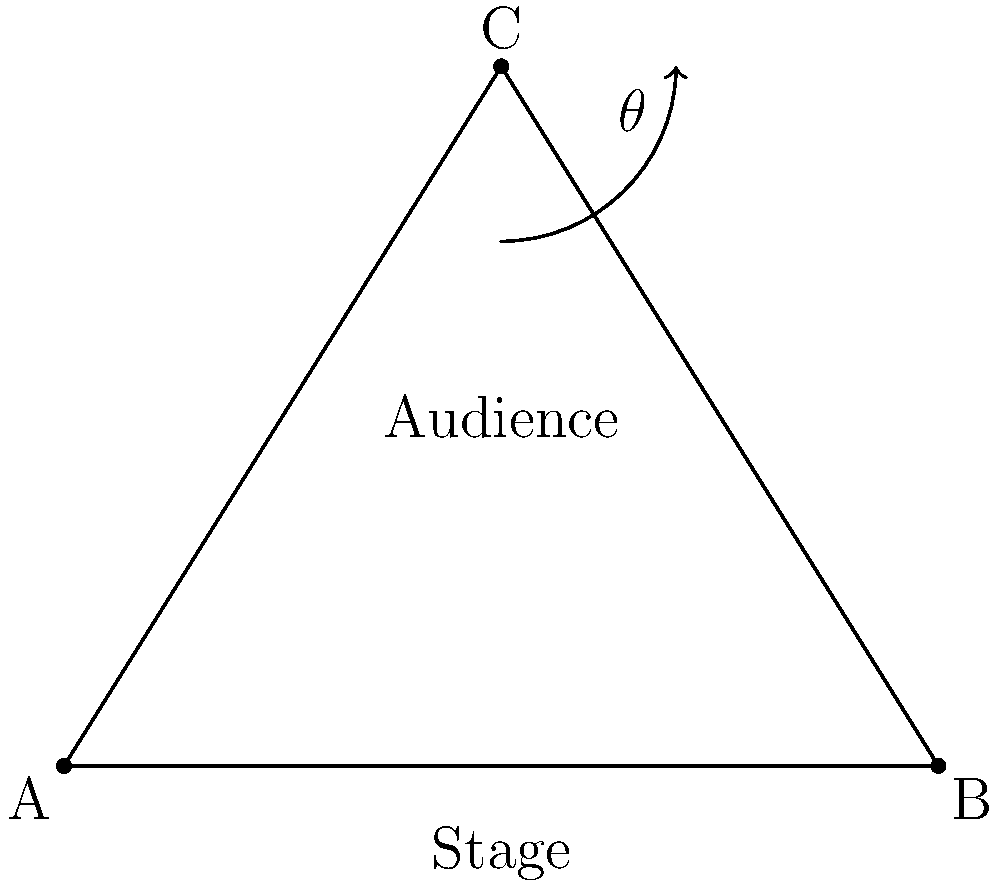In the floor plan for a motivational presentation stage setup, what is the optimal angle $\theta$ for the stage layout to ensure maximum audience engagement and visibility? To determine the optimal angle for the stage layout, we need to consider the principles of presentation design and audience engagement. Here's a step-by-step explanation:

1. The stage layout forms an isosceles triangle ABC, where AB is the stage front and C is the apex point.

2. For optimal visibility and engagement, we want to maximize the angle $\theta$ at point C. This allows for better sight lines and a more immersive experience for the audience.

3. In an isosceles triangle, the largest angle is always opposite the base (in this case, AB). The sum of angles in a triangle is always 180°.

4. To maximize $\theta$, we need to make the other two angles (at A and B) as small as possible while still maintaining a practical stage layout.

5. The most effective compromise between stage width and audience depth is achieved when the triangle is equilateral, meaning all angles are equal.

6. In an equilateral triangle, each angle measures 60°.

7. Therefore, the optimal angle $\theta$ at point C should be 60°.

This 60° angle allows for a balanced distribution of the audience, provides good visibility from all seats, and creates an engaging atmosphere that aligns with the goals of a motivational presentation.
Answer: 60° 